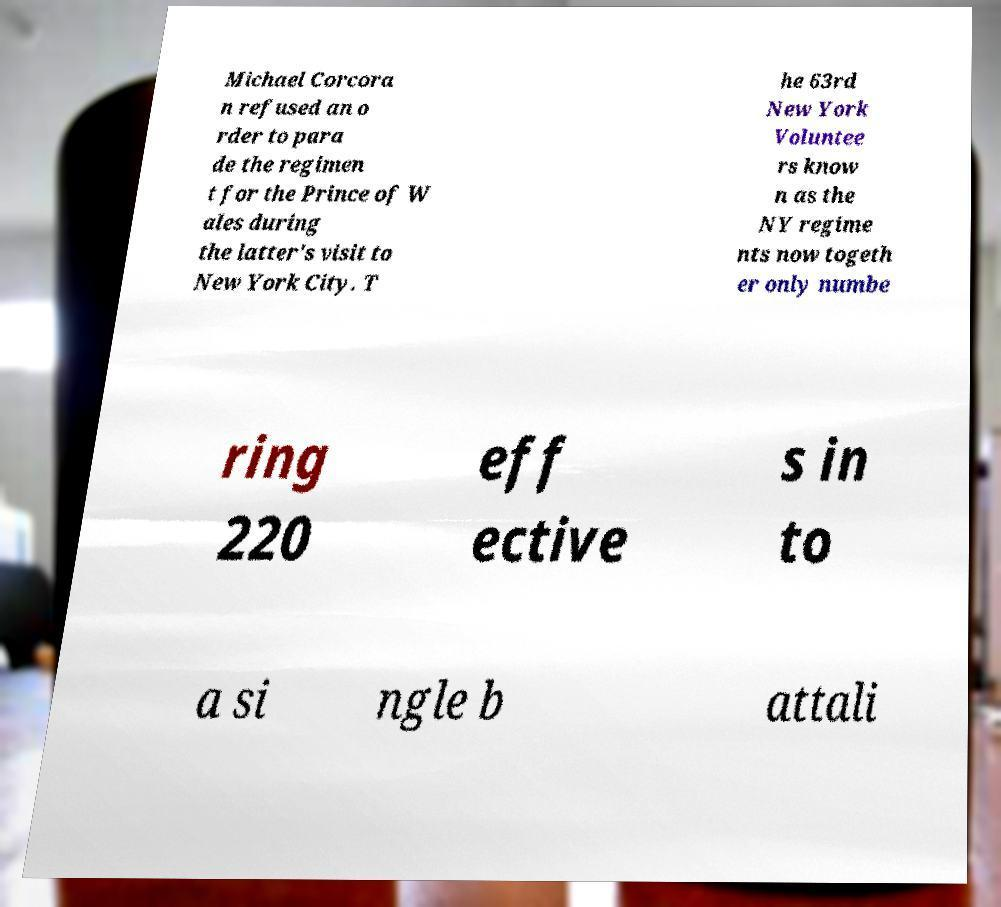Could you assist in decoding the text presented in this image and type it out clearly? Michael Corcora n refused an o rder to para de the regimen t for the Prince of W ales during the latter's visit to New York City. T he 63rd New York Voluntee rs know n as the NY regime nts now togeth er only numbe ring 220 eff ective s in to a si ngle b attali 